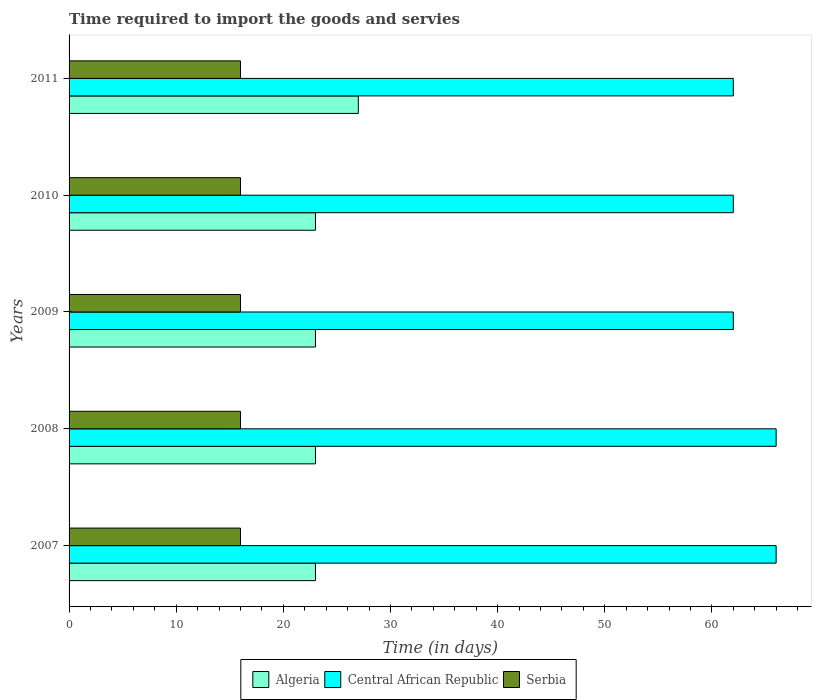How many bars are there on the 1st tick from the bottom?
Your response must be concise. 3. What is the label of the 5th group of bars from the top?
Your response must be concise. 2007. What is the number of days required to import the goods and services in Serbia in 2008?
Provide a succinct answer. 16. Across all years, what is the maximum number of days required to import the goods and services in Algeria?
Offer a terse response. 27. Across all years, what is the minimum number of days required to import the goods and services in Central African Republic?
Keep it short and to the point. 62. In which year was the number of days required to import the goods and services in Serbia maximum?
Provide a short and direct response. 2007. In which year was the number of days required to import the goods and services in Central African Republic minimum?
Your response must be concise. 2009. What is the total number of days required to import the goods and services in Serbia in the graph?
Ensure brevity in your answer.  80. What is the difference between the number of days required to import the goods and services in Algeria in 2007 and that in 2011?
Offer a very short reply. -4. What is the difference between the number of days required to import the goods and services in Serbia in 2011 and the number of days required to import the goods and services in Central African Republic in 2008?
Ensure brevity in your answer.  -50. What is the average number of days required to import the goods and services in Serbia per year?
Give a very brief answer. 16. In the year 2009, what is the difference between the number of days required to import the goods and services in Central African Republic and number of days required to import the goods and services in Serbia?
Make the answer very short. 46. What is the ratio of the number of days required to import the goods and services in Algeria in 2008 to that in 2009?
Make the answer very short. 1. Is the number of days required to import the goods and services in Serbia in 2007 less than that in 2010?
Your answer should be compact. No. What is the difference between the highest and the lowest number of days required to import the goods and services in Algeria?
Offer a terse response. 4. What does the 2nd bar from the top in 2009 represents?
Ensure brevity in your answer.  Central African Republic. What does the 1st bar from the bottom in 2008 represents?
Keep it short and to the point. Algeria. Is it the case that in every year, the sum of the number of days required to import the goods and services in Algeria and number of days required to import the goods and services in Serbia is greater than the number of days required to import the goods and services in Central African Republic?
Give a very brief answer. No. Are all the bars in the graph horizontal?
Your answer should be compact. Yes. How many years are there in the graph?
Keep it short and to the point. 5. Does the graph contain any zero values?
Your answer should be very brief. No. Where does the legend appear in the graph?
Your answer should be compact. Bottom center. How many legend labels are there?
Provide a succinct answer. 3. What is the title of the graph?
Provide a succinct answer. Time required to import the goods and servies. Does "Costa Rica" appear as one of the legend labels in the graph?
Your answer should be compact. No. What is the label or title of the X-axis?
Keep it short and to the point. Time (in days). What is the Time (in days) of Algeria in 2007?
Keep it short and to the point. 23. What is the Time (in days) in Algeria in 2008?
Keep it short and to the point. 23. What is the Time (in days) in Central African Republic in 2008?
Offer a very short reply. 66. What is the Time (in days) in Serbia in 2008?
Offer a terse response. 16. What is the Time (in days) in Serbia in 2009?
Ensure brevity in your answer.  16. What is the Time (in days) of Algeria in 2010?
Offer a terse response. 23. What is the Time (in days) in Central African Republic in 2010?
Your answer should be compact. 62. What is the Time (in days) of Serbia in 2010?
Provide a succinct answer. 16. Across all years, what is the maximum Time (in days) of Central African Republic?
Keep it short and to the point. 66. Across all years, what is the minimum Time (in days) of Serbia?
Your answer should be compact. 16. What is the total Time (in days) of Algeria in the graph?
Make the answer very short. 119. What is the total Time (in days) of Central African Republic in the graph?
Ensure brevity in your answer.  318. What is the difference between the Time (in days) in Algeria in 2007 and that in 2008?
Your answer should be very brief. 0. What is the difference between the Time (in days) in Serbia in 2007 and that in 2008?
Provide a short and direct response. 0. What is the difference between the Time (in days) in Serbia in 2007 and that in 2009?
Offer a terse response. 0. What is the difference between the Time (in days) of Algeria in 2007 and that in 2010?
Offer a terse response. 0. What is the difference between the Time (in days) of Central African Republic in 2007 and that in 2010?
Offer a very short reply. 4. What is the difference between the Time (in days) of Algeria in 2007 and that in 2011?
Your answer should be compact. -4. What is the difference between the Time (in days) of Central African Republic in 2007 and that in 2011?
Offer a terse response. 4. What is the difference between the Time (in days) of Serbia in 2007 and that in 2011?
Give a very brief answer. 0. What is the difference between the Time (in days) of Central African Republic in 2008 and that in 2009?
Offer a terse response. 4. What is the difference between the Time (in days) of Serbia in 2008 and that in 2009?
Offer a terse response. 0. What is the difference between the Time (in days) of Algeria in 2008 and that in 2010?
Provide a succinct answer. 0. What is the difference between the Time (in days) in Central African Republic in 2008 and that in 2010?
Your response must be concise. 4. What is the difference between the Time (in days) in Serbia in 2008 and that in 2010?
Your answer should be compact. 0. What is the difference between the Time (in days) in Algeria in 2008 and that in 2011?
Provide a short and direct response. -4. What is the difference between the Time (in days) in Central African Republic in 2009 and that in 2010?
Your answer should be compact. 0. What is the difference between the Time (in days) in Algeria in 2009 and that in 2011?
Provide a succinct answer. -4. What is the difference between the Time (in days) of Central African Republic in 2009 and that in 2011?
Your answer should be very brief. 0. What is the difference between the Time (in days) of Serbia in 2009 and that in 2011?
Your answer should be compact. 0. What is the difference between the Time (in days) of Central African Republic in 2010 and that in 2011?
Offer a terse response. 0. What is the difference between the Time (in days) in Algeria in 2007 and the Time (in days) in Central African Republic in 2008?
Provide a short and direct response. -43. What is the difference between the Time (in days) of Algeria in 2007 and the Time (in days) of Serbia in 2008?
Offer a terse response. 7. What is the difference between the Time (in days) in Algeria in 2007 and the Time (in days) in Central African Republic in 2009?
Ensure brevity in your answer.  -39. What is the difference between the Time (in days) of Central African Republic in 2007 and the Time (in days) of Serbia in 2009?
Give a very brief answer. 50. What is the difference between the Time (in days) in Algeria in 2007 and the Time (in days) in Central African Republic in 2010?
Your response must be concise. -39. What is the difference between the Time (in days) of Algeria in 2007 and the Time (in days) of Serbia in 2010?
Your answer should be compact. 7. What is the difference between the Time (in days) of Algeria in 2007 and the Time (in days) of Central African Republic in 2011?
Provide a short and direct response. -39. What is the difference between the Time (in days) of Algeria in 2008 and the Time (in days) of Central African Republic in 2009?
Give a very brief answer. -39. What is the difference between the Time (in days) of Algeria in 2008 and the Time (in days) of Central African Republic in 2010?
Give a very brief answer. -39. What is the difference between the Time (in days) in Algeria in 2008 and the Time (in days) in Serbia in 2010?
Ensure brevity in your answer.  7. What is the difference between the Time (in days) in Algeria in 2008 and the Time (in days) in Central African Republic in 2011?
Make the answer very short. -39. What is the difference between the Time (in days) of Algeria in 2009 and the Time (in days) of Central African Republic in 2010?
Your answer should be very brief. -39. What is the difference between the Time (in days) in Algeria in 2009 and the Time (in days) in Serbia in 2010?
Your response must be concise. 7. What is the difference between the Time (in days) of Algeria in 2009 and the Time (in days) of Central African Republic in 2011?
Keep it short and to the point. -39. What is the difference between the Time (in days) of Algeria in 2009 and the Time (in days) of Serbia in 2011?
Offer a very short reply. 7. What is the difference between the Time (in days) of Algeria in 2010 and the Time (in days) of Central African Republic in 2011?
Make the answer very short. -39. What is the difference between the Time (in days) of Central African Republic in 2010 and the Time (in days) of Serbia in 2011?
Offer a very short reply. 46. What is the average Time (in days) in Algeria per year?
Offer a very short reply. 23.8. What is the average Time (in days) of Central African Republic per year?
Keep it short and to the point. 63.6. What is the average Time (in days) of Serbia per year?
Provide a succinct answer. 16. In the year 2007, what is the difference between the Time (in days) of Algeria and Time (in days) of Central African Republic?
Make the answer very short. -43. In the year 2008, what is the difference between the Time (in days) of Algeria and Time (in days) of Central African Republic?
Provide a short and direct response. -43. In the year 2008, what is the difference between the Time (in days) in Central African Republic and Time (in days) in Serbia?
Provide a short and direct response. 50. In the year 2009, what is the difference between the Time (in days) of Algeria and Time (in days) of Central African Republic?
Ensure brevity in your answer.  -39. In the year 2009, what is the difference between the Time (in days) of Central African Republic and Time (in days) of Serbia?
Provide a short and direct response. 46. In the year 2010, what is the difference between the Time (in days) of Algeria and Time (in days) of Central African Republic?
Provide a succinct answer. -39. In the year 2011, what is the difference between the Time (in days) of Algeria and Time (in days) of Central African Republic?
Your answer should be compact. -35. In the year 2011, what is the difference between the Time (in days) in Central African Republic and Time (in days) in Serbia?
Offer a very short reply. 46. What is the ratio of the Time (in days) of Algeria in 2007 to that in 2008?
Keep it short and to the point. 1. What is the ratio of the Time (in days) of Central African Republic in 2007 to that in 2008?
Give a very brief answer. 1. What is the ratio of the Time (in days) in Algeria in 2007 to that in 2009?
Keep it short and to the point. 1. What is the ratio of the Time (in days) of Central African Republic in 2007 to that in 2009?
Keep it short and to the point. 1.06. What is the ratio of the Time (in days) of Serbia in 2007 to that in 2009?
Ensure brevity in your answer.  1. What is the ratio of the Time (in days) in Central African Republic in 2007 to that in 2010?
Offer a terse response. 1.06. What is the ratio of the Time (in days) in Algeria in 2007 to that in 2011?
Your response must be concise. 0.85. What is the ratio of the Time (in days) of Central African Republic in 2007 to that in 2011?
Ensure brevity in your answer.  1.06. What is the ratio of the Time (in days) in Serbia in 2007 to that in 2011?
Provide a succinct answer. 1. What is the ratio of the Time (in days) of Central African Republic in 2008 to that in 2009?
Your response must be concise. 1.06. What is the ratio of the Time (in days) of Serbia in 2008 to that in 2009?
Provide a short and direct response. 1. What is the ratio of the Time (in days) of Central African Republic in 2008 to that in 2010?
Keep it short and to the point. 1.06. What is the ratio of the Time (in days) of Algeria in 2008 to that in 2011?
Keep it short and to the point. 0.85. What is the ratio of the Time (in days) in Central African Republic in 2008 to that in 2011?
Give a very brief answer. 1.06. What is the ratio of the Time (in days) of Serbia in 2008 to that in 2011?
Ensure brevity in your answer.  1. What is the ratio of the Time (in days) in Central African Republic in 2009 to that in 2010?
Your response must be concise. 1. What is the ratio of the Time (in days) in Algeria in 2009 to that in 2011?
Offer a very short reply. 0.85. What is the ratio of the Time (in days) in Central African Republic in 2009 to that in 2011?
Give a very brief answer. 1. What is the ratio of the Time (in days) in Algeria in 2010 to that in 2011?
Provide a short and direct response. 0.85. What is the ratio of the Time (in days) of Central African Republic in 2010 to that in 2011?
Provide a short and direct response. 1. What is the difference between the highest and the second highest Time (in days) in Serbia?
Keep it short and to the point. 0. What is the difference between the highest and the lowest Time (in days) in Algeria?
Provide a succinct answer. 4. What is the difference between the highest and the lowest Time (in days) in Central African Republic?
Your answer should be compact. 4. What is the difference between the highest and the lowest Time (in days) in Serbia?
Give a very brief answer. 0. 